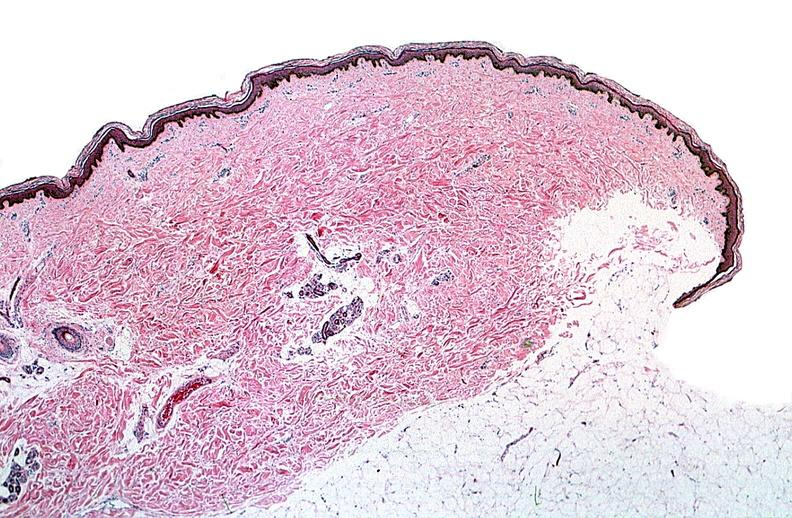what does this image show?
Answer the question using a single word or phrase. Thermal burned skin 